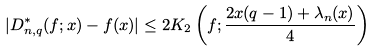Convert formula to latex. <formula><loc_0><loc_0><loc_500><loc_500>| D _ { n , q } ^ { * } ( f ; x ) - f ( x ) | \leq 2 K _ { 2 } \left ( f ; \frac { 2 x ( q - 1 ) + \lambda _ { n } ( x ) } { 4 } \right )</formula> 